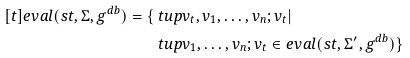<formula> <loc_0><loc_0><loc_500><loc_500>[ t ] e v a l ( s t , \Sigma , g ^ { d b } ) = \{ & \ t u p { v _ { t } , v _ { 1 } , \dots , v _ { n } ; v _ { t } } | \\ & \ t u p { v _ { 1 } , \dots , v _ { n } ; v _ { t } } \in e v a l ( s t , \Sigma ^ { \prime } , g ^ { d b } ) \}</formula> 